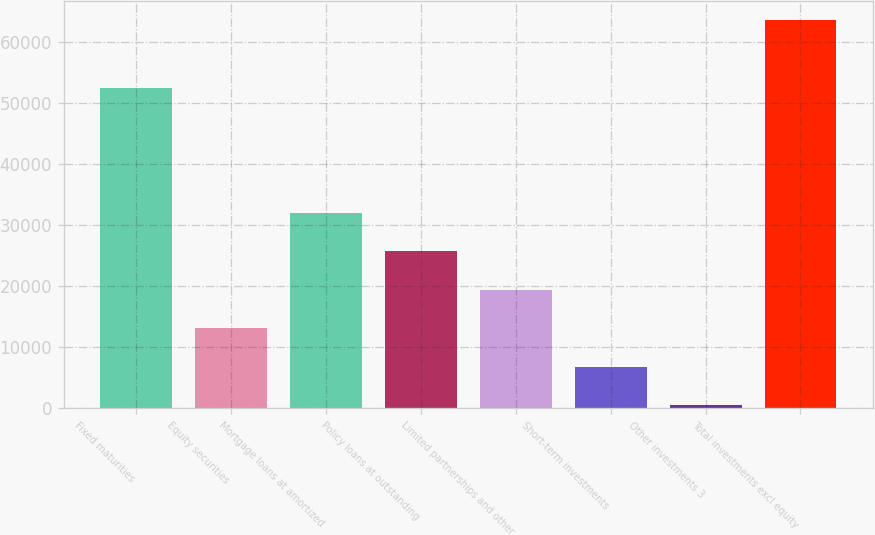Convert chart. <chart><loc_0><loc_0><loc_500><loc_500><bar_chart><fcel>Fixed maturities<fcel>Equity securities<fcel>Mortgage loans at amortized<fcel>Policy loans at outstanding<fcel>Limited partnerships and other<fcel>Short-term investments<fcel>Other investments 3<fcel>Total investments excl equity<nl><fcel>52542<fcel>13152<fcel>32079<fcel>25770<fcel>19461<fcel>6843<fcel>534<fcel>63624<nl></chart> 